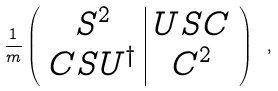<formula> <loc_0><loc_0><loc_500><loc_500>\frac { 1 } { m } \left ( \begin{array} { c | c } S ^ { 2 } & U S C \\ C S U ^ { \dagger } & C ^ { 2 } \end{array} \right ) \ ,</formula> 